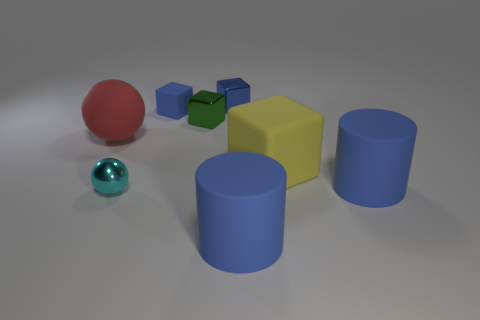There is a yellow object; is its size the same as the matte object that is left of the blue rubber cube? Upon examining the image, it appears that the size of the yellow object, which is a cube, is indeed very similar to that of the matte green cube located to the left of the larger blue rubber cube. Both cubes exhibit dimensions that, while not identical, are closely comparable in a visual assessment. 